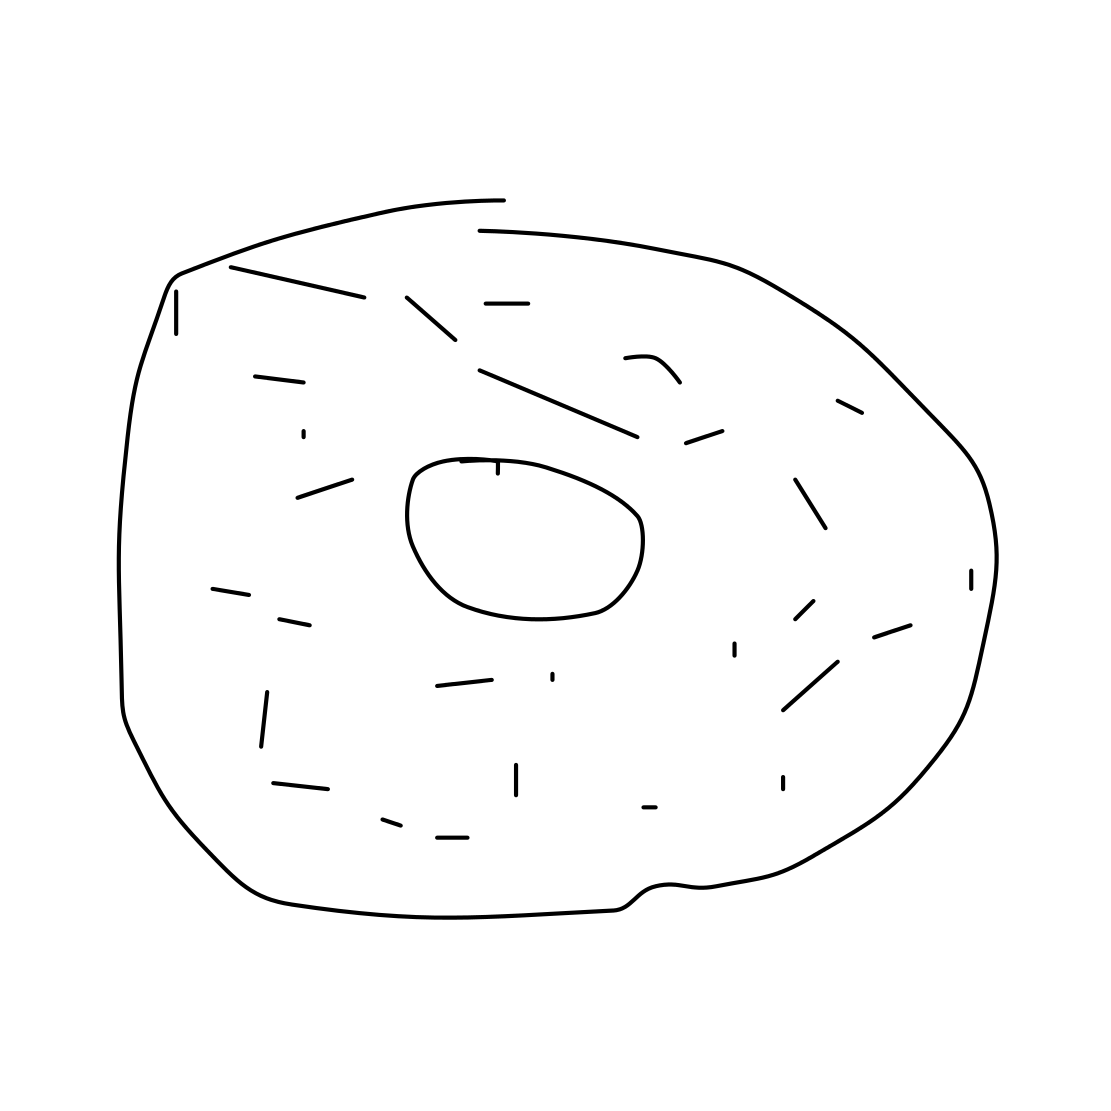If this donut were part of a larger breakfast, what might accompany it? A well-rounded breakfast featuring this donut could include a savory item like scrambled eggs or bacon to balance the sweetness. A cup of coffee, tea, or a glass of milk would complement the flavors nicely. For a healthier addition, a side of fresh fruit would offer a refreshing contrast. 